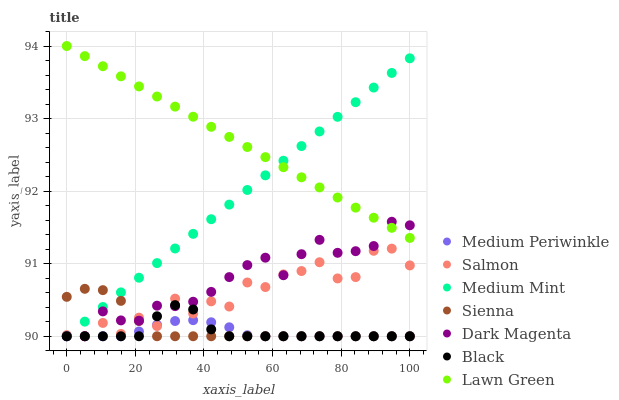Does Medium Periwinkle have the minimum area under the curve?
Answer yes or no. Yes. Does Lawn Green have the maximum area under the curve?
Answer yes or no. Yes. Does Dark Magenta have the minimum area under the curve?
Answer yes or no. No. Does Dark Magenta have the maximum area under the curve?
Answer yes or no. No. Is Medium Mint the smoothest?
Answer yes or no. Yes. Is Salmon the roughest?
Answer yes or no. Yes. Is Lawn Green the smoothest?
Answer yes or no. No. Is Lawn Green the roughest?
Answer yes or no. No. Does Medium Mint have the lowest value?
Answer yes or no. Yes. Does Lawn Green have the lowest value?
Answer yes or no. No. Does Lawn Green have the highest value?
Answer yes or no. Yes. Does Dark Magenta have the highest value?
Answer yes or no. No. Is Black less than Lawn Green?
Answer yes or no. Yes. Is Lawn Green greater than Sienna?
Answer yes or no. Yes. Does Sienna intersect Black?
Answer yes or no. Yes. Is Sienna less than Black?
Answer yes or no. No. Is Sienna greater than Black?
Answer yes or no. No. Does Black intersect Lawn Green?
Answer yes or no. No. 